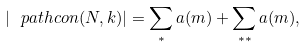Convert formula to latex. <formula><loc_0><loc_0><loc_500><loc_500>| \ p a t h c o n ( N , k ) | = \sum _ { * } a ( m ) + \sum _ { * * } a ( m ) ,</formula> 